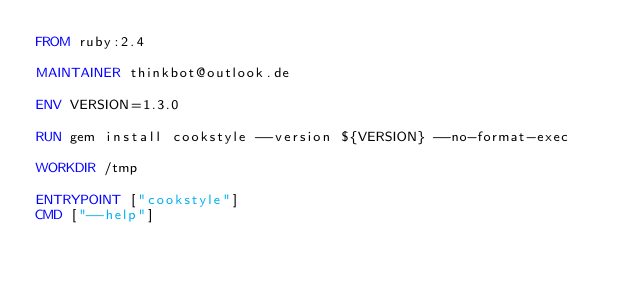<code> <loc_0><loc_0><loc_500><loc_500><_Dockerfile_>FROM ruby:2.4

MAINTAINER thinkbot@outlook.de

ENV VERSION=1.3.0

RUN gem install cookstyle --version ${VERSION} --no-format-exec

WORKDIR /tmp

ENTRYPOINT ["cookstyle"]
CMD ["--help"]
</code> 